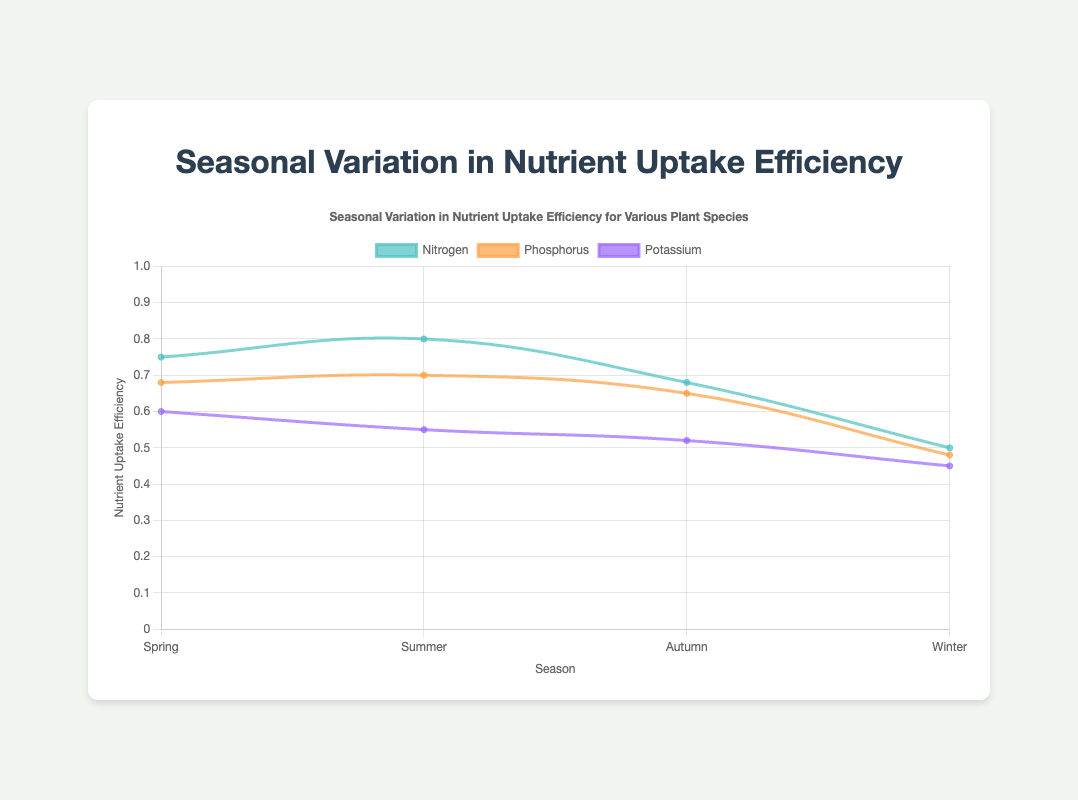What is the nutrient with the highest uptake efficiency in Spring? By observing the plot, we see that Nitrogen has the highest nutrient uptake efficiency in Spring with a value of 0.75.
Answer: Nitrogen How does Nitrogen uptake efficiency compare between Spring and Winter? Comparing the Nitrogen uptake efficiencies from Spring (0.75) and Winter (0.50), it is clear that the uptake efficiency is higher in Spring.
Answer: Higher in Spring Which season shows the lowest uptake efficiency for Potassium? By looking at the potassium uptake efficiencies across different seasons, Winter has the lowest value, which is 0.45.
Answer: Winter What is the average Nitrogen uptake efficiency across all seasons? Average Nitrogen uptake efficiency is calculated as (0.75 + 0.80 + 0.68 + 0.50) / 4 = 0.6825.
Answer: 0.6825 Is Potassium uptake efficiency in Autumn higher, lower, or the same as in Summer? Potassium uptake efficiency in Summer is 0.55 and in Autumn is 0.52, therefore, it is lower in Autumn.
Answer: Lower Which season has the highest average uptake efficiency across all nutrients? By calculating the average uptake efficiencies: Spring (0.674), Summer (0.683), Autumn (0.616), Winter (0.486), Summer has the highest average uptake efficiency.
Answer: Summer What is the difference in Phosphorus uptake efficiency between Summer and Winter? Phosphorus uptake efficiency is 0.70 in Summer and 0.48 in Winter. The difference is 0.70 - 0.48 = 0.22.
Answer: 0.22 Among all the visual lines (Nitrogen, Phosphorus, Potassium), which nutrient shows a decreasing trend from Spring to Winter? Both Phosphorus and Potassium lines show a consistent decreasing trend from Spring to Winter.
Answer: Phosphorus and Potassium Comparing the uptake efficiencies for Nitrogen and Potassium in Summer, which is more efficient? The uptake efficiency for Nitrogen in Summer is 0.80, and for Potassium it is 0.55. Thus, Nitrogen is significantly more efficient.
Answer: Nitrogen What is the average uptake efficiency for Zea mays across all the nutrients in Spring? The average is calculated by (0.75 + 0.68 + 0.60) / 3 = 0.6767.
Answer: 0.6767 